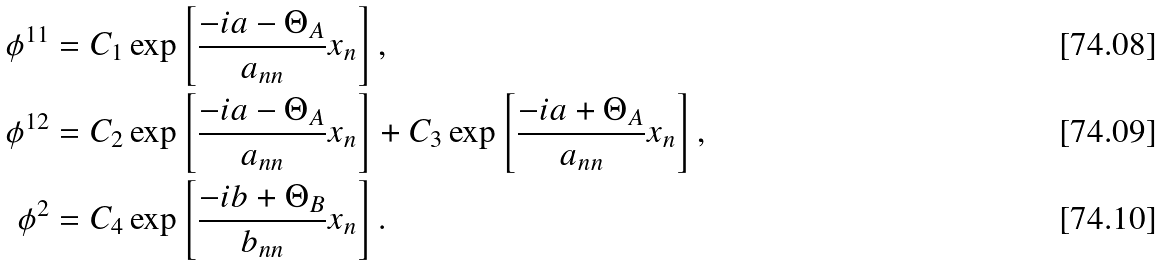<formula> <loc_0><loc_0><loc_500><loc_500>\phi ^ { 1 1 } & = C _ { 1 } \exp \left [ \frac { - i a - \Theta _ { A } } { a _ { n n } } x _ { n } \right ] , \\ \phi ^ { 1 2 } & = C _ { 2 } \exp \left [ \frac { - i a - \Theta _ { A } } { a _ { n n } } x _ { n } \right ] + C _ { 3 } \exp \left [ \frac { - i a + \Theta _ { A } } { a _ { n n } } x _ { n } \right ] , \\ \phi ^ { 2 } & = C _ { 4 } \exp \left [ \frac { - i b + \Theta _ { B } } { b _ { n n } } x _ { n } \right ] .</formula> 